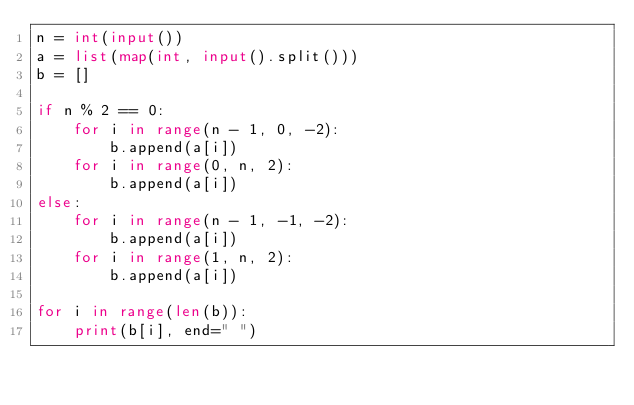<code> <loc_0><loc_0><loc_500><loc_500><_Python_>n = int(input())
a = list(map(int, input().split()))
b = []

if n % 2 == 0:
    for i in range(n - 1, 0, -2):
        b.append(a[i])
    for i in range(0, n, 2):
        b.append(a[i])
else:
    for i in range(n - 1, -1, -2):
        b.append(a[i])
    for i in range(1, n, 2):
        b.append(a[i])

for i in range(len(b)):
    print(b[i], end=" ")
</code> 